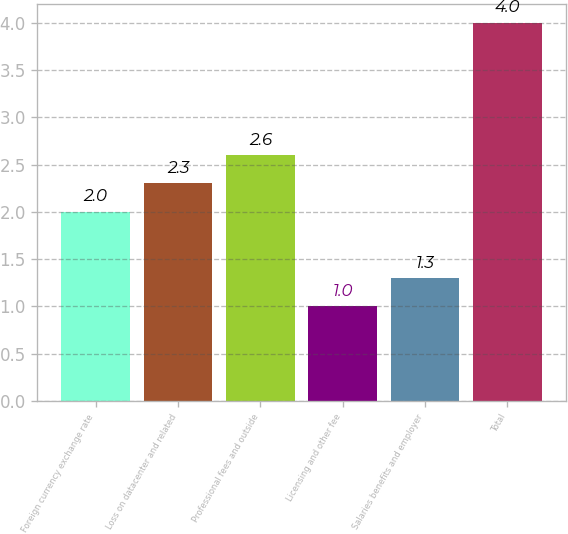Convert chart to OTSL. <chart><loc_0><loc_0><loc_500><loc_500><bar_chart><fcel>Foreign currency exchange rate<fcel>Loss on datacenter and related<fcel>Professional fees and outside<fcel>Licensing and other fee<fcel>Salaries benefits and employer<fcel>Total<nl><fcel>2<fcel>2.3<fcel>2.6<fcel>1<fcel>1.3<fcel>4<nl></chart> 